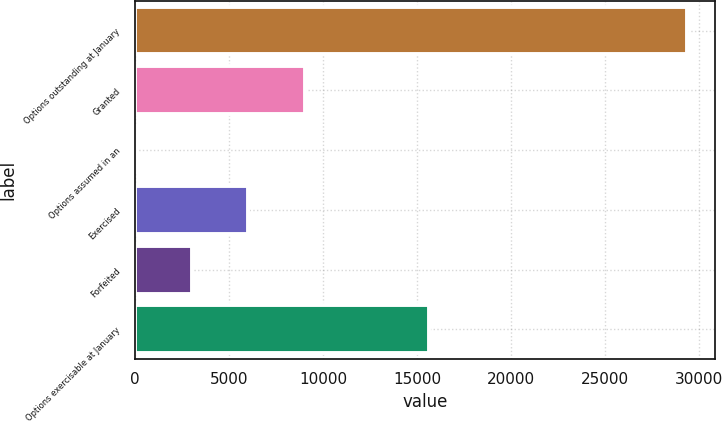<chart> <loc_0><loc_0><loc_500><loc_500><bar_chart><fcel>Options outstanding at January<fcel>Granted<fcel>Options assumed in an<fcel>Exercised<fcel>Forfeited<fcel>Options exercisable at January<nl><fcel>29374<fcel>9021<fcel>12<fcel>6018<fcel>3015<fcel>15626<nl></chart> 